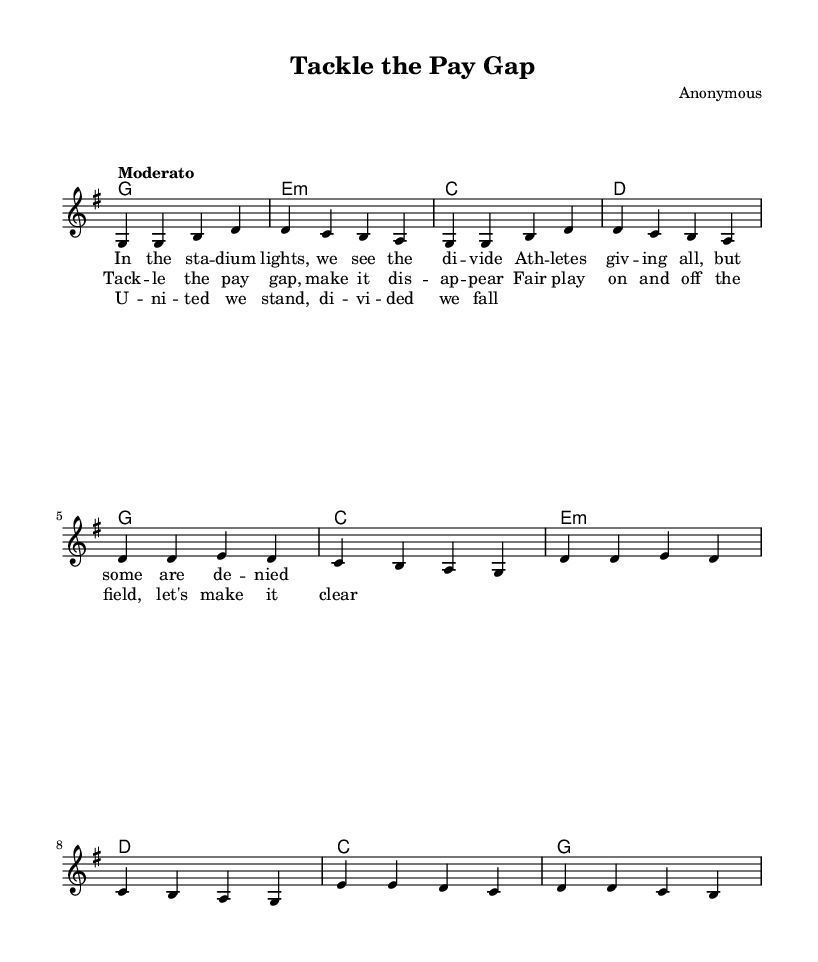What is the key signature of this music? The key signature is indicated at the beginning of the sheet music, showing one sharp for G major.
Answer: G major What is the time signature used in this piece? The time signature is found at the beginning of the music, displaying a 4 over 4, which indicates four beats per measure.
Answer: 4/4 What tempo marking is given for this piece? The tempo marking is noted in the score, indicating "Moderato," which suggests a moderate speed for the performance.
Answer: Moderato How many measures are in the verse section? By counting the measures in the melody and harmonies sections that correspond to the verse lyrics, there are four measures.
Answer: 4 What is the main theme of the chorus lyrics? Analyzing the chorus lyrics, the main theme emphasizes addressing the pay gap and advocating for fair play on and off the field.
Answer: Tackling the pay gap What chord is played in the bridge section? Looking at the harmonies specified for the bridge, the chords listed indicate a transition primarily involving C and G.
Answer: C, G What social issue is addressed in the song? Examining the lyrics and overall theme, the song addresses the issue of inequality, particularly focusing on the pay gap in professional sports.
Answer: Pay gap 